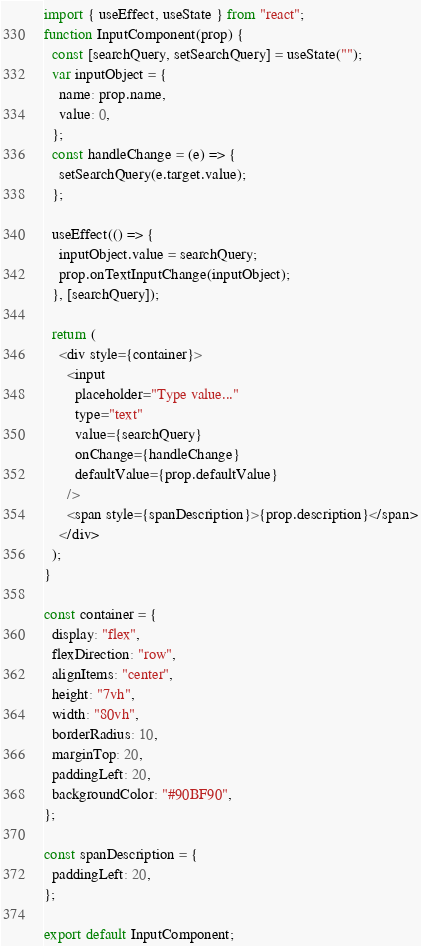Convert code to text. <code><loc_0><loc_0><loc_500><loc_500><_JavaScript_>import { useEffect, useState } from "react";
function InputComponent(prop) {
  const [searchQuery, setSearchQuery] = useState("");
  var inputObject = {
    name: prop.name,
    value: 0,
  };
  const handleChange = (e) => {
    setSearchQuery(e.target.value);
  };

  useEffect(() => {
    inputObject.value = searchQuery;
    prop.onTextInputChange(inputObject);
  }, [searchQuery]);

  return (
    <div style={container}>
      <input
        placeholder="Type value..."
        type="text"
        value={searchQuery}
        onChange={handleChange}
        defaultValue={prop.defaultValue}
      />
      <span style={spanDescription}>{prop.description}</span>
    </div>
  );
}

const container = {
  display: "flex",
  flexDirection: "row",
  alignItems: "center",
  height: "7vh",
  width: "80vh",
  borderRadius: 10,
  marginTop: 20,
  paddingLeft: 20,
  backgroundColor: "#90BF90",
};

const spanDescription = {
  paddingLeft: 20,
};

export default InputComponent;
</code> 